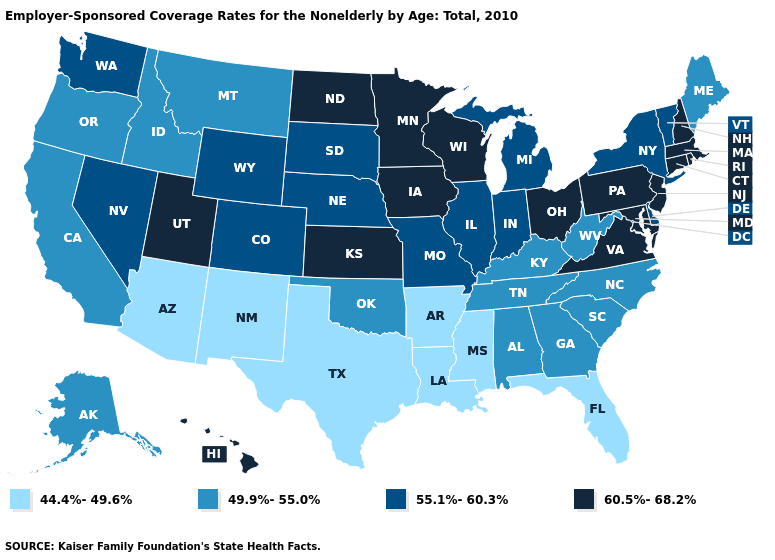Does the first symbol in the legend represent the smallest category?
Write a very short answer. Yes. What is the value of Alabama?
Keep it brief. 49.9%-55.0%. What is the value of Montana?
Keep it brief. 49.9%-55.0%. What is the highest value in states that border Texas?
Give a very brief answer. 49.9%-55.0%. Among the states that border Tennessee , which have the highest value?
Quick response, please. Virginia. Does Ohio have the highest value in the USA?
Write a very short answer. Yes. What is the value of Indiana?
Quick response, please. 55.1%-60.3%. Which states hav the highest value in the South?
Quick response, please. Maryland, Virginia. What is the lowest value in the Northeast?
Answer briefly. 49.9%-55.0%. Name the states that have a value in the range 55.1%-60.3%?
Quick response, please. Colorado, Delaware, Illinois, Indiana, Michigan, Missouri, Nebraska, Nevada, New York, South Dakota, Vermont, Washington, Wyoming. Name the states that have a value in the range 49.9%-55.0%?
Write a very short answer. Alabama, Alaska, California, Georgia, Idaho, Kentucky, Maine, Montana, North Carolina, Oklahoma, Oregon, South Carolina, Tennessee, West Virginia. What is the highest value in the Northeast ?
Short answer required. 60.5%-68.2%. What is the value of Indiana?
Quick response, please. 55.1%-60.3%. Among the states that border Michigan , does Indiana have the lowest value?
Concise answer only. Yes. Which states hav the highest value in the Northeast?
Keep it brief. Connecticut, Massachusetts, New Hampshire, New Jersey, Pennsylvania, Rhode Island. 